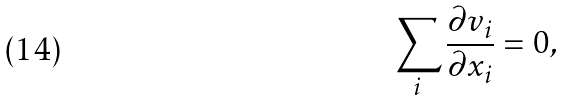Convert formula to latex. <formula><loc_0><loc_0><loc_500><loc_500>\sum _ { i } \frac { \partial v _ { i } } { \partial x _ { i } } = 0 ,</formula> 